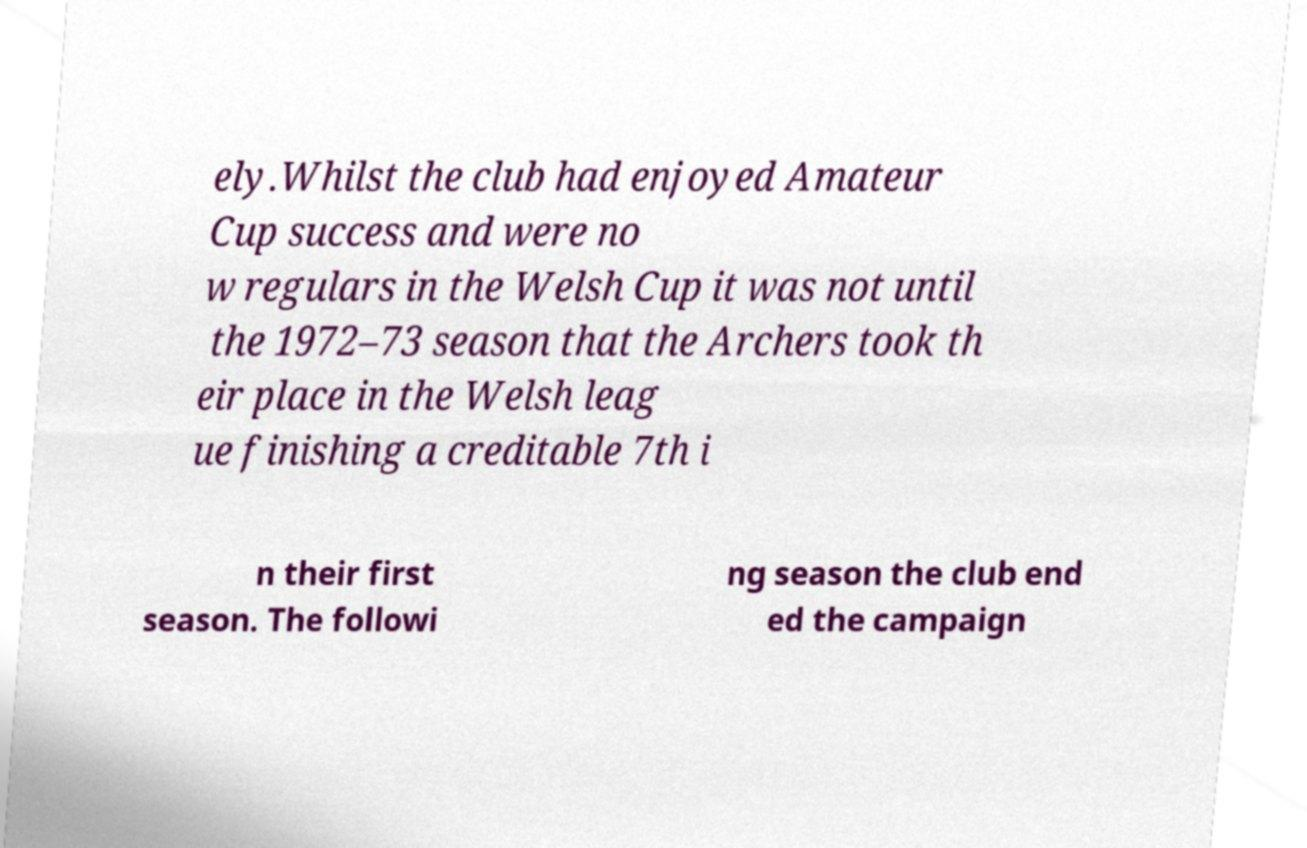Could you assist in decoding the text presented in this image and type it out clearly? ely.Whilst the club had enjoyed Amateur Cup success and were no w regulars in the Welsh Cup it was not until the 1972–73 season that the Archers took th eir place in the Welsh leag ue finishing a creditable 7th i n their first season. The followi ng season the club end ed the campaign 